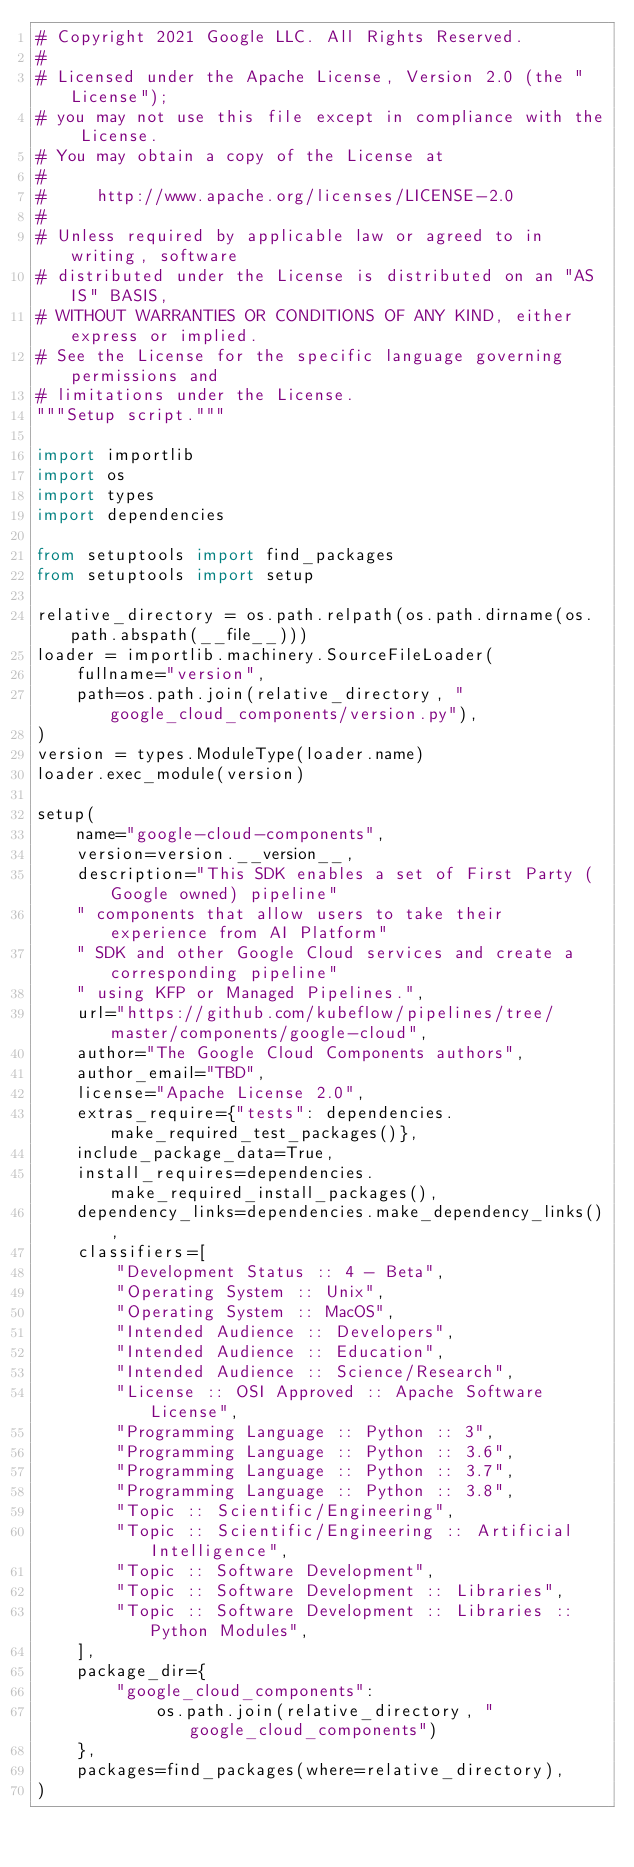Convert code to text. <code><loc_0><loc_0><loc_500><loc_500><_Python_># Copyright 2021 Google LLC. All Rights Reserved.
#
# Licensed under the Apache License, Version 2.0 (the "License");
# you may not use this file except in compliance with the License.
# You may obtain a copy of the License at
#
#     http://www.apache.org/licenses/LICENSE-2.0
#
# Unless required by applicable law or agreed to in writing, software
# distributed under the License is distributed on an "AS IS" BASIS,
# WITHOUT WARRANTIES OR CONDITIONS OF ANY KIND, either express or implied.
# See the License for the specific language governing permissions and
# limitations under the License.
"""Setup script."""

import importlib
import os
import types
import dependencies

from setuptools import find_packages
from setuptools import setup

relative_directory = os.path.relpath(os.path.dirname(os.path.abspath(__file__)))
loader = importlib.machinery.SourceFileLoader(
    fullname="version",
    path=os.path.join(relative_directory, "google_cloud_components/version.py"),
)
version = types.ModuleType(loader.name)
loader.exec_module(version)

setup(
    name="google-cloud-components",
    version=version.__version__,
    description="This SDK enables a set of First Party (Google owned) pipeline"
    " components that allow users to take their experience from AI Platform"
    " SDK and other Google Cloud services and create a corresponding pipeline"
    " using KFP or Managed Pipelines.",
    url="https://github.com/kubeflow/pipelines/tree/master/components/google-cloud",
    author="The Google Cloud Components authors",
    author_email="TBD",
    license="Apache License 2.0",
    extras_require={"tests": dependencies.make_required_test_packages()},
    include_package_data=True,
    install_requires=dependencies.make_required_install_packages(),
    dependency_links=dependencies.make_dependency_links(),
    classifiers=[
        "Development Status :: 4 - Beta",
        "Operating System :: Unix",
        "Operating System :: MacOS",
        "Intended Audience :: Developers",
        "Intended Audience :: Education",
        "Intended Audience :: Science/Research",
        "License :: OSI Approved :: Apache Software License",
        "Programming Language :: Python :: 3",
        "Programming Language :: Python :: 3.6",
        "Programming Language :: Python :: 3.7",
        "Programming Language :: Python :: 3.8",
        "Topic :: Scientific/Engineering",
        "Topic :: Scientific/Engineering :: Artificial Intelligence",
        "Topic :: Software Development",
        "Topic :: Software Development :: Libraries",
        "Topic :: Software Development :: Libraries :: Python Modules",
    ],
    package_dir={
        "google_cloud_components":
            os.path.join(relative_directory, "google_cloud_components")
    },
    packages=find_packages(where=relative_directory),
)
</code> 